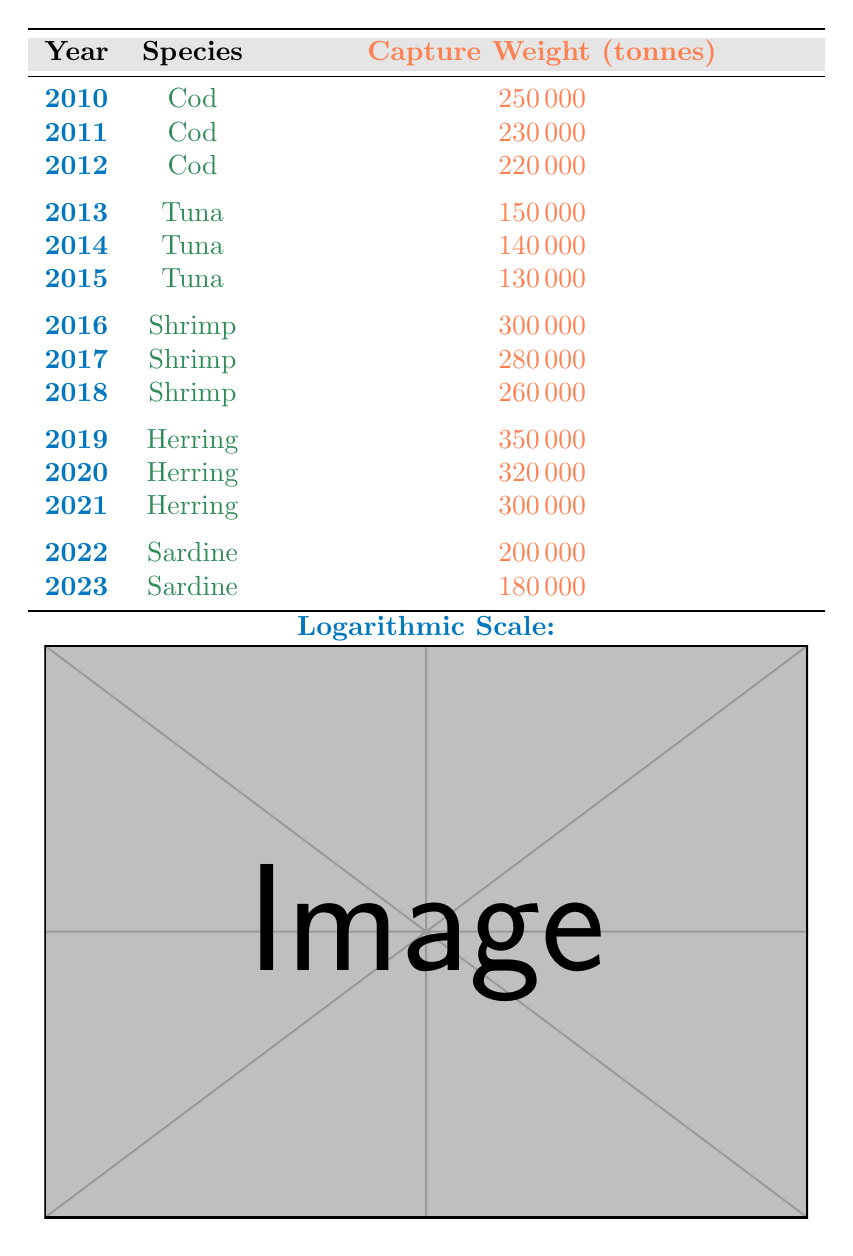What was the capture weight of Cod in 2011? The table lists the capture weight of Cod in 2011, which is directly stated as 230000 tonnes.
Answer: 230000 tonnes Which species had the highest capture weight in 2019? According to the table, Herring was captured at a weight of 350000 tonnes in 2019, which is the highest value compared to other species in that year.
Answer: Herring What was the total capture weight of all Tuna species over the years? By adding the capture weights for Tuna from 2013 to 2015: 150000 + 140000 + 130000 = 420000 tonnes. Thus, the total capture weight of all Tuna species over the reported years is 420000 tonnes.
Answer: 420000 tonnes Did the capture weight of Shrimp decrease every year from 2016 to 2018? From the table, the capture weights for Shrimp are 300000 (2016), 280000 (2017), and 260000 (2018), indicating a consistent decrease in weight each year.
Answer: Yes What is the average capture weight of Sardine from 2022 to 2023? The capture weights for Sardine are 200000 (2022) and 180000 (2023). Adding them gives 200000 + 180000 = 380000, and dividing by the number of years (2) gives an average of 380000 / 2 = 190000 tonnes.
Answer: 190000 tonnes Which species had the lowest capture weight in a single year? Inspecting the table, Tuna had the lowest capture weight in 2015 at 130000 tonnes compared to other weights for different species.
Answer: Tuna (130000 tonnes) Is there a species that increased in capture weight from one year to the next? By analyzing the data, no species shows an increase in capture weight from one year to the next; all species listed demonstrate a decline or fluctuating capture weights.
Answer: No What is the difference in capture weight of Herring between 2019 and 2021? The weights for Herring in 2019 and 2021 are 350000 and 300000 tonnes, respectively. The difference is 350000 - 300000 = 50000 tonnes.
Answer: 50000 tonnes 